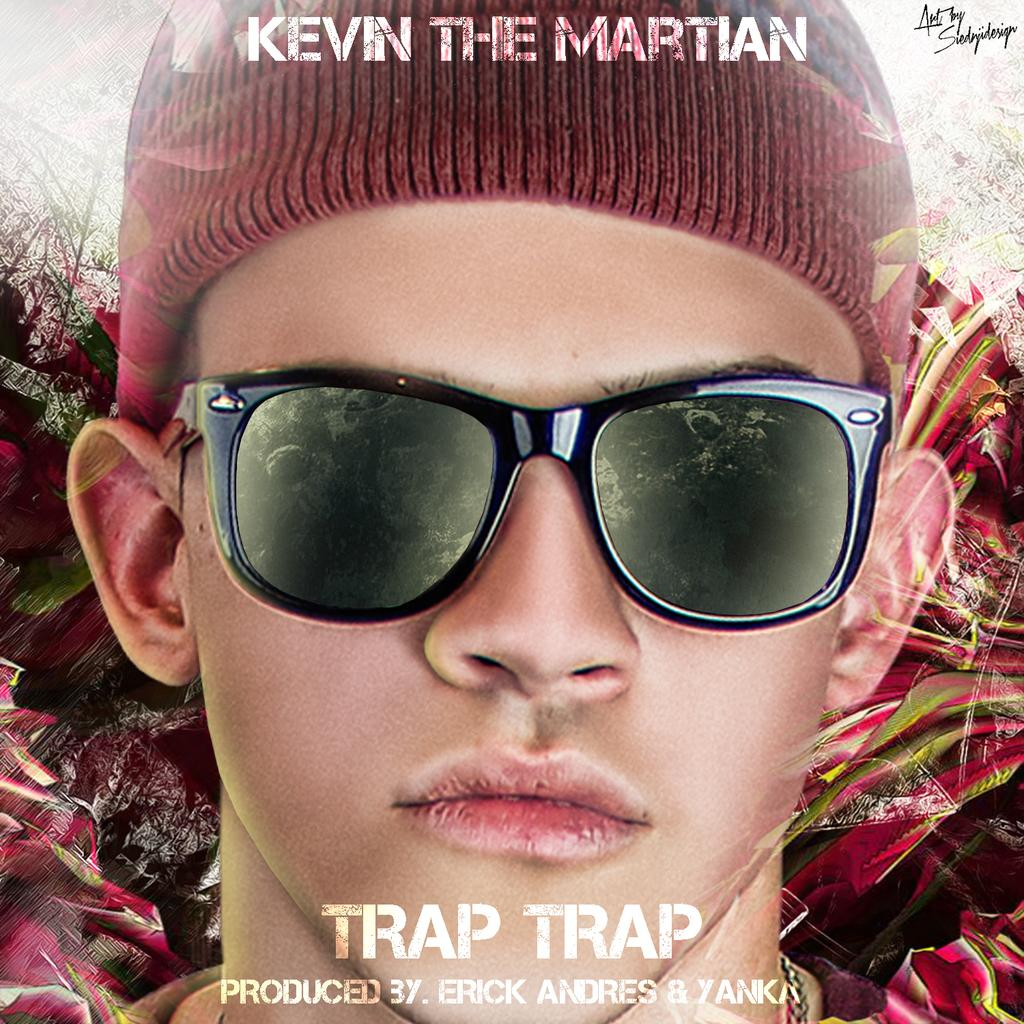<image>
Share a concise interpretation of the image provided. A closeup ad photo of Kevin the Martian, he is wearing glasses and a tobagan. 